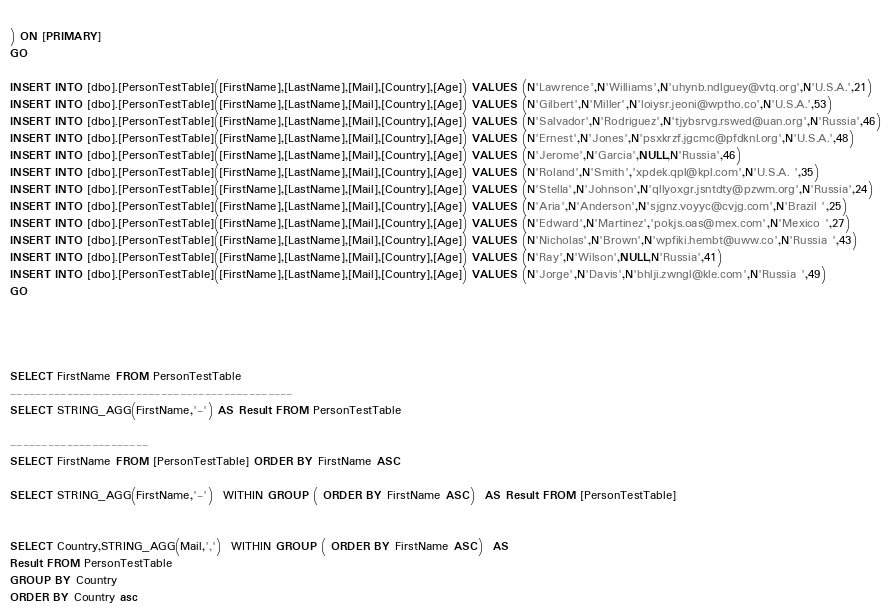Convert code to text. <code><loc_0><loc_0><loc_500><loc_500><_SQL_>    
) ON [PRIMARY]
GO
    
INSERT INTO [dbo].[PersonTestTable]([FirstName],[LastName],[Mail],[Country],[Age]) VALUES (N'Lawrence',N'Williams',N'uhynb.ndlguey@vtq.org',N'U.S.A.',21)
INSERT INTO [dbo].[PersonTestTable]([FirstName],[LastName],[Mail],[Country],[Age]) VALUES (N'Gilbert',N'Miller',N'loiysr.jeoni@wptho.co',N'U.S.A.',53)
INSERT INTO [dbo].[PersonTestTable]([FirstName],[LastName],[Mail],[Country],[Age]) VALUES (N'Salvador',N'Rodriguez',N'tjybsrvg.rswed@uan.org',N'Russia',46)
INSERT INTO [dbo].[PersonTestTable]([FirstName],[LastName],[Mail],[Country],[Age]) VALUES (N'Ernest',N'Jones',N'psxkrzf.jgcmc@pfdknl.org',N'U.S.A.',48)
INSERT INTO [dbo].[PersonTestTable]([FirstName],[LastName],[Mail],[Country],[Age]) VALUES (N'Jerome',N'Garcia',NULL,N'Russia',46)
INSERT INTO [dbo].[PersonTestTable]([FirstName],[LastName],[Mail],[Country],[Age]) VALUES (N'Roland',N'Smith','xpdek.qpl@kpl.com',N'U.S.A. ',35)
INSERT INTO [dbo].[PersonTestTable]([FirstName],[LastName],[Mail],[Country],[Age]) VALUES (N'Stella',N'Johnson',N'qllyoxgr.jsntdty@pzwm.org',N'Russia',24)
INSERT INTO [dbo].[PersonTestTable]([FirstName],[LastName],[Mail],[Country],[Age]) VALUES (N'Aria',N'Anderson',N'sjgnz.voyyc@cvjg.com',N'Brazil ',25)
INSERT INTO [dbo].[PersonTestTable]([FirstName],[LastName],[Mail],[Country],[Age]) VALUES (N'Edward',N'Martinez','pokjs.oas@mex.com',N'Mexico ',27)
INSERT INTO [dbo].[PersonTestTable]([FirstName],[LastName],[Mail],[Country],[Age]) VALUES (N'Nicholas',N'Brown',N'wpfiki.hembt@uww.co',N'Russia ',43)
INSERT INTO [dbo].[PersonTestTable]([FirstName],[LastName],[Mail],[Country],[Age]) VALUES (N'Ray',N'Wilson',NULL,N'Russia',41)
INSERT INTO [dbo].[PersonTestTable]([FirstName],[LastName],[Mail],[Country],[Age]) VALUES (N'Jorge',N'Davis',N'bhlji.zwngl@kle.com',N'Russia ',49)
GO




SELECT FirstName FROM PersonTestTable
---------------------------------------------
SELECT STRING_AGG(FirstName,'-') AS Result FROM PersonTestTable

----------------------
SELECT FirstName FROM [PersonTestTable] ORDER BY FirstName ASC

SELECT STRING_AGG(FirstName,'-')  WITHIN GROUP ( ORDER BY FirstName ASC)  AS Result FROM [PersonTestTable]


SELECT Country,STRING_AGG(Mail,',')  WITHIN GROUP ( ORDER BY FirstName ASC)  AS
Result FROM PersonTestTable
GROUP BY Country
ORDER BY Country asc</code> 